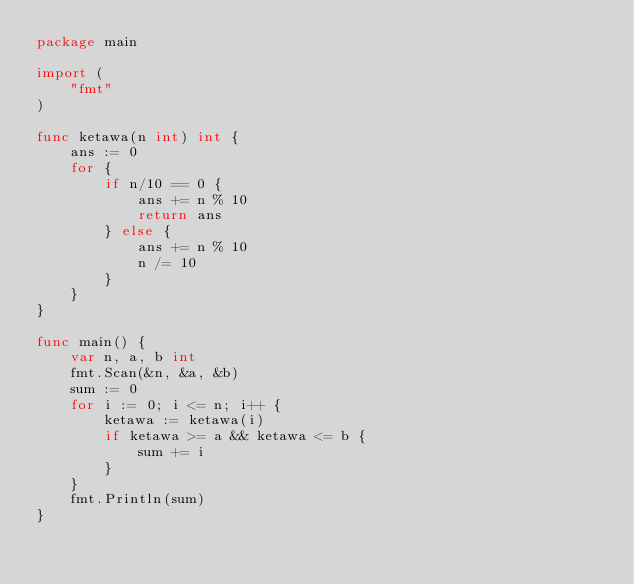<code> <loc_0><loc_0><loc_500><loc_500><_Go_>package main

import (
	"fmt"
)

func ketawa(n int) int {
	ans := 0
	for {
		if n/10 == 0 {
			ans += n % 10
			return ans
		} else {
			ans += n % 10
			n /= 10
		}
	}
}

func main() {
	var n, a, b int
	fmt.Scan(&n, &a, &b)
	sum := 0
	for i := 0; i <= n; i++ {
		ketawa := ketawa(i)
		if ketawa >= a && ketawa <= b {
			sum += i
		}
	}
	fmt.Println(sum)
}
</code> 